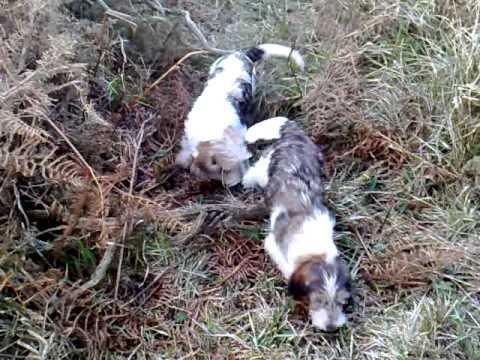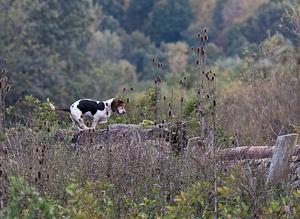The first image is the image on the left, the second image is the image on the right. Analyze the images presented: Is the assertion "Each image includes at least one horse and multiple beagles, and at least one image includes a rider wearing red." valid? Answer yes or no. No. The first image is the image on the left, the second image is the image on the right. For the images shown, is this caption "People in coats are riding horses with several dogs in the image on the left." true? Answer yes or no. No. 